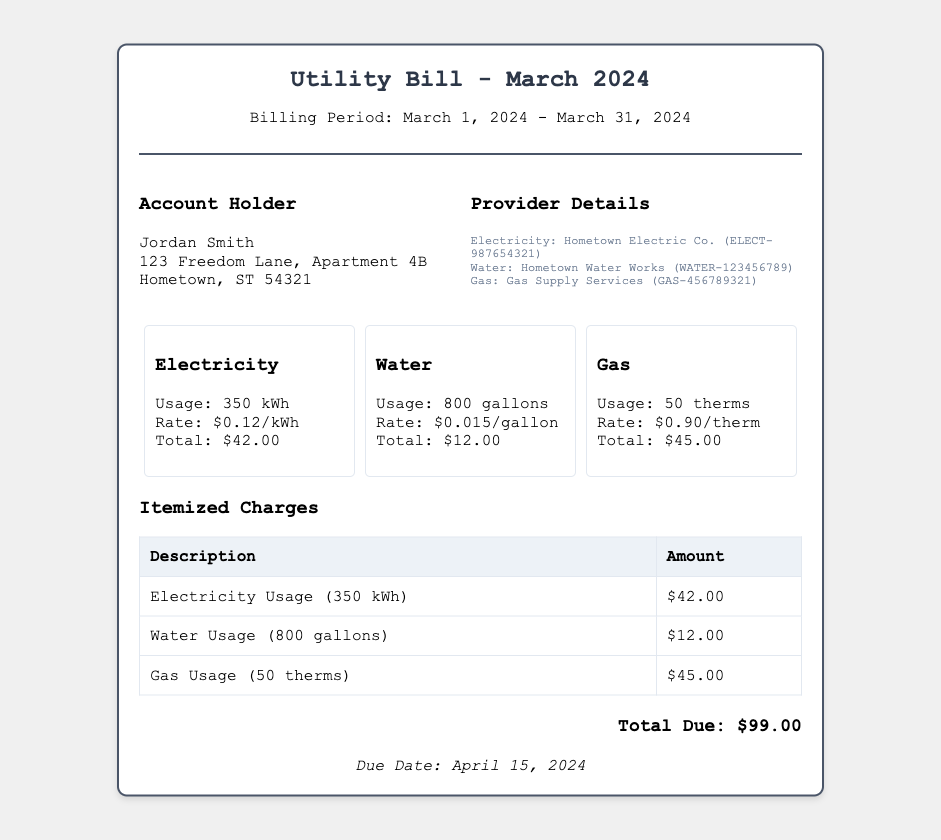What is the billing period? The billing period is indicated under the header, which specifies the start and end dates for the bill.
Answer: March 1, 2024 - March 31, 2024 Who is the account holder? The account holder's information is detailed in the account info section.
Answer: Jordan Smith What is the total electricity usage? The total electricity usage is provided in the electricity details section.
Answer: 350 kWh What is the rate for water usage? The rate for water usage is stated in the water usage details.
Answer: $0.015/gallon What is the total due amount? The total amount that is due is highlighted at the bottom of the bill.
Answer: $99.00 Which service has the highest charge? The itemized charges section details each service and their corresponding amounts, allowing comparison.
Answer: Gas Usage When is the due date for the bill? The due date is mentioned at the bottom of the bill.
Answer: April 15, 2024 How much is charged per therm for gas? This rate is outlined in the gas usage section of the bill.
Answer: $0.90/therm What is the total water usage? The total water usage is clearly stated in the water usage details section.
Answer: 800 gallons 